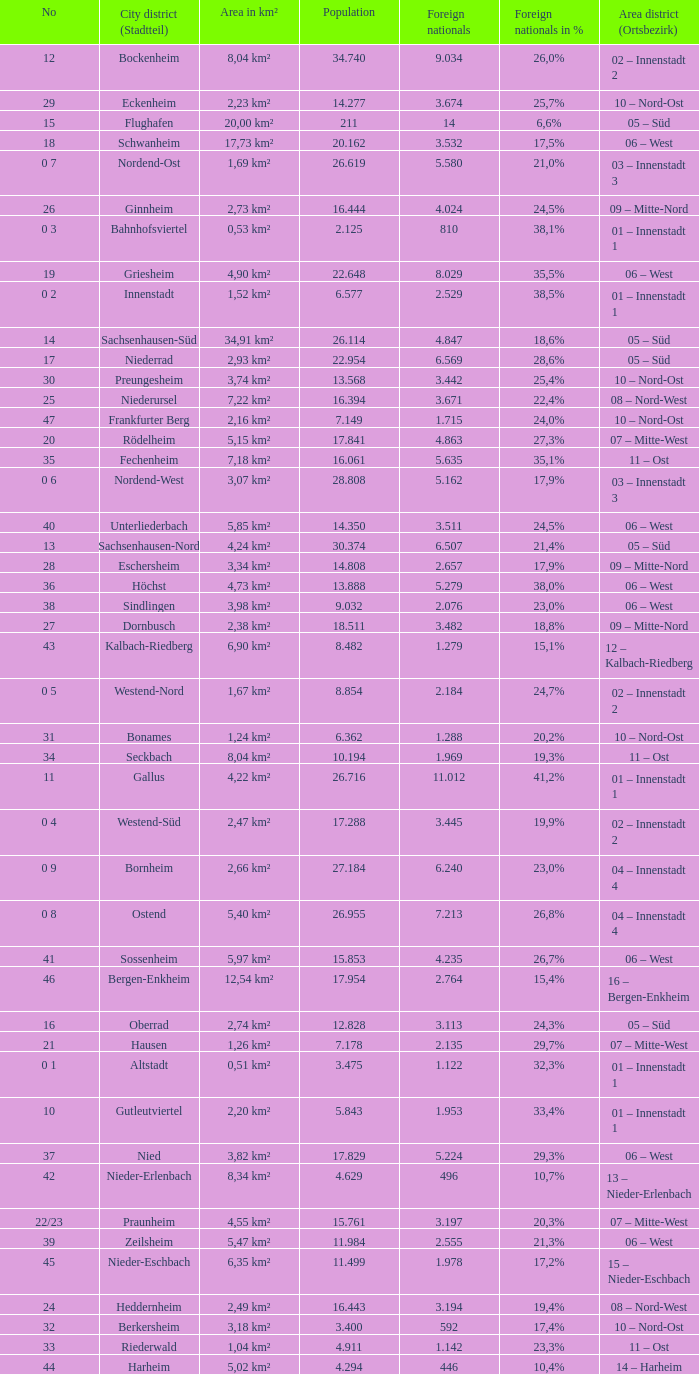How many foreigners in percentage terms had a population of 4.911? 1.0. 